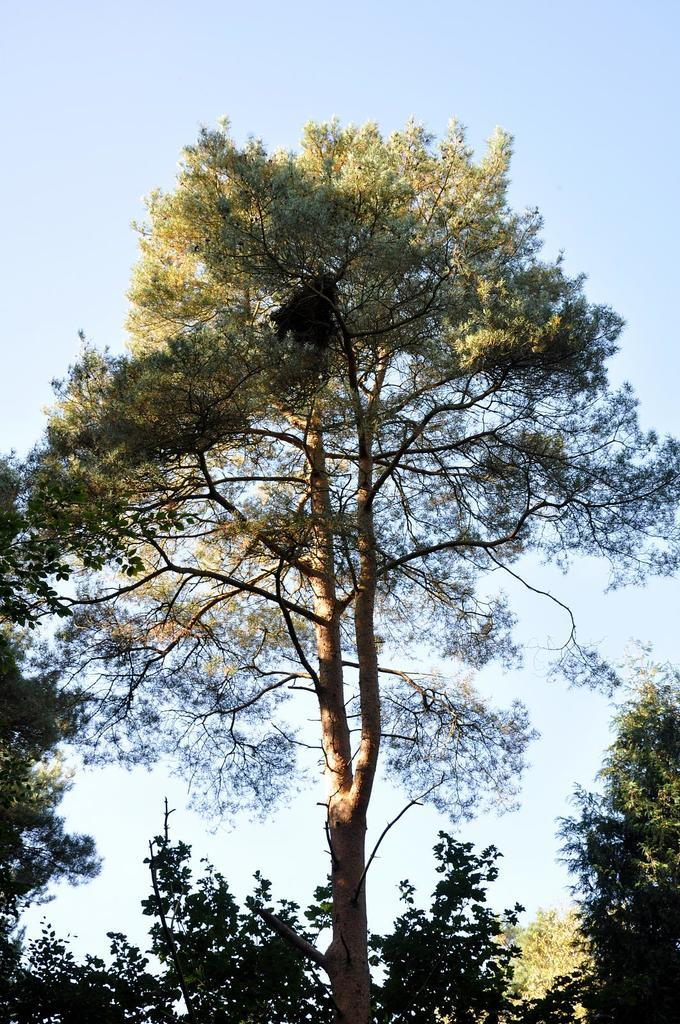What type of vegetation is present in the front of the image? There are trees in the front of the image. What part of the natural environment can be seen in the background of the image? The sky is visible in the background of the image. What color is the suit worn by the person in the image? There is no person wearing a suit in the image; it only features trees and the sky. How many times does the throat appear in the image? There is no throat present in the image, as it only contains trees and the sky. 